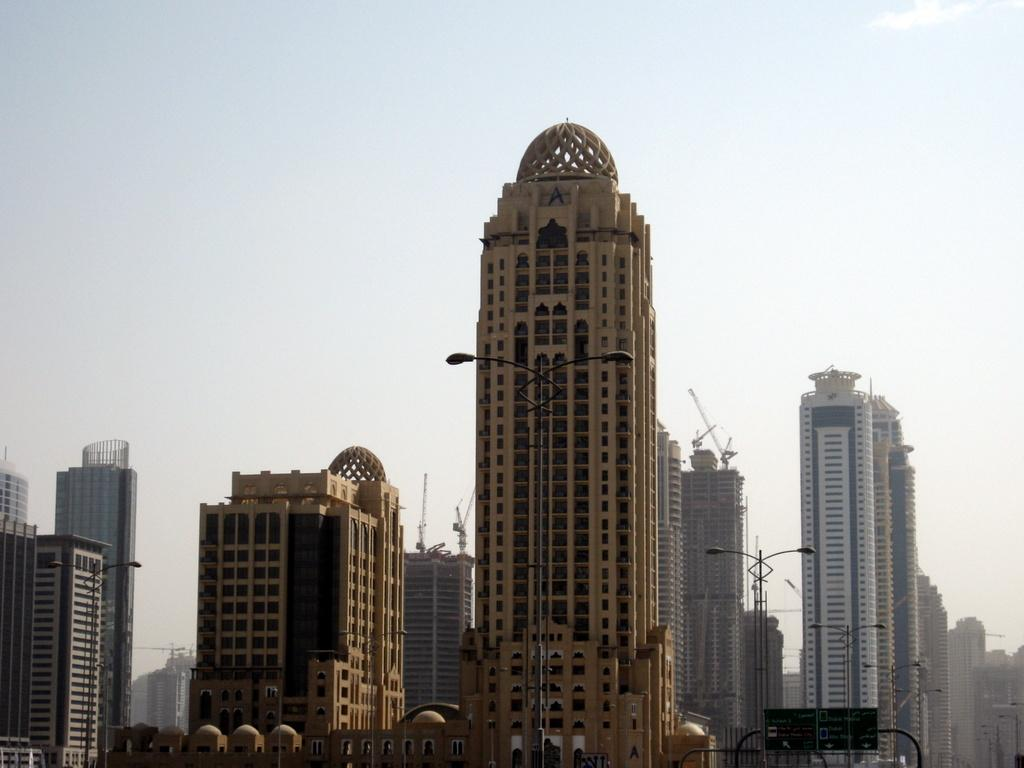What type of structures can be seen in the image? There are buildings in the image. What other objects are present in the image? There are poles, lights, and boards in the image. What can be seen in the background of the image? The sky is visible in the background of the image. What groundbreaking theory is being discussed on the boards in the image? There is no indication in the image that any theory is being discussed on the boards. The boards may contain advertisements, notices, or other information, but there is no way to determine the content of the boards from the image alone. 